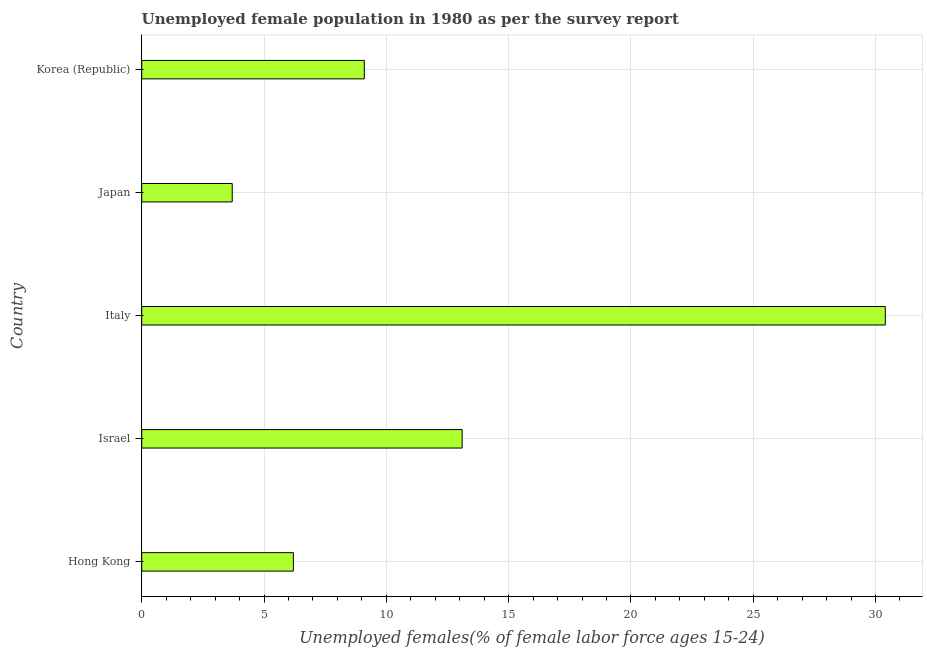Does the graph contain any zero values?
Offer a terse response. No. What is the title of the graph?
Keep it short and to the point. Unemployed female population in 1980 as per the survey report. What is the label or title of the X-axis?
Offer a terse response. Unemployed females(% of female labor force ages 15-24). What is the unemployed female youth in Israel?
Your response must be concise. 13.1. Across all countries, what is the maximum unemployed female youth?
Offer a very short reply. 30.4. Across all countries, what is the minimum unemployed female youth?
Offer a very short reply. 3.7. What is the sum of the unemployed female youth?
Offer a very short reply. 62.5. What is the difference between the unemployed female youth in Israel and Italy?
Your answer should be compact. -17.3. What is the average unemployed female youth per country?
Offer a very short reply. 12.5. What is the median unemployed female youth?
Your response must be concise. 9.1. What is the ratio of the unemployed female youth in Israel to that in Japan?
Provide a short and direct response. 3.54. Is the sum of the unemployed female youth in Italy and Japan greater than the maximum unemployed female youth across all countries?
Provide a succinct answer. Yes. What is the difference between the highest and the lowest unemployed female youth?
Provide a succinct answer. 26.7. In how many countries, is the unemployed female youth greater than the average unemployed female youth taken over all countries?
Keep it short and to the point. 2. How many bars are there?
Offer a terse response. 5. How many countries are there in the graph?
Ensure brevity in your answer.  5. What is the difference between two consecutive major ticks on the X-axis?
Your response must be concise. 5. Are the values on the major ticks of X-axis written in scientific E-notation?
Keep it short and to the point. No. What is the Unemployed females(% of female labor force ages 15-24) in Hong Kong?
Ensure brevity in your answer.  6.2. What is the Unemployed females(% of female labor force ages 15-24) of Israel?
Provide a succinct answer. 13.1. What is the Unemployed females(% of female labor force ages 15-24) of Italy?
Your response must be concise. 30.4. What is the Unemployed females(% of female labor force ages 15-24) of Japan?
Keep it short and to the point. 3.7. What is the Unemployed females(% of female labor force ages 15-24) in Korea (Republic)?
Keep it short and to the point. 9.1. What is the difference between the Unemployed females(% of female labor force ages 15-24) in Hong Kong and Italy?
Make the answer very short. -24.2. What is the difference between the Unemployed females(% of female labor force ages 15-24) in Israel and Italy?
Your answer should be compact. -17.3. What is the difference between the Unemployed females(% of female labor force ages 15-24) in Italy and Japan?
Your answer should be very brief. 26.7. What is the difference between the Unemployed females(% of female labor force ages 15-24) in Italy and Korea (Republic)?
Your response must be concise. 21.3. What is the ratio of the Unemployed females(% of female labor force ages 15-24) in Hong Kong to that in Israel?
Offer a terse response. 0.47. What is the ratio of the Unemployed females(% of female labor force ages 15-24) in Hong Kong to that in Italy?
Make the answer very short. 0.2. What is the ratio of the Unemployed females(% of female labor force ages 15-24) in Hong Kong to that in Japan?
Offer a terse response. 1.68. What is the ratio of the Unemployed females(% of female labor force ages 15-24) in Hong Kong to that in Korea (Republic)?
Give a very brief answer. 0.68. What is the ratio of the Unemployed females(% of female labor force ages 15-24) in Israel to that in Italy?
Offer a very short reply. 0.43. What is the ratio of the Unemployed females(% of female labor force ages 15-24) in Israel to that in Japan?
Your response must be concise. 3.54. What is the ratio of the Unemployed females(% of female labor force ages 15-24) in Israel to that in Korea (Republic)?
Offer a very short reply. 1.44. What is the ratio of the Unemployed females(% of female labor force ages 15-24) in Italy to that in Japan?
Your response must be concise. 8.22. What is the ratio of the Unemployed females(% of female labor force ages 15-24) in Italy to that in Korea (Republic)?
Provide a succinct answer. 3.34. What is the ratio of the Unemployed females(% of female labor force ages 15-24) in Japan to that in Korea (Republic)?
Make the answer very short. 0.41. 